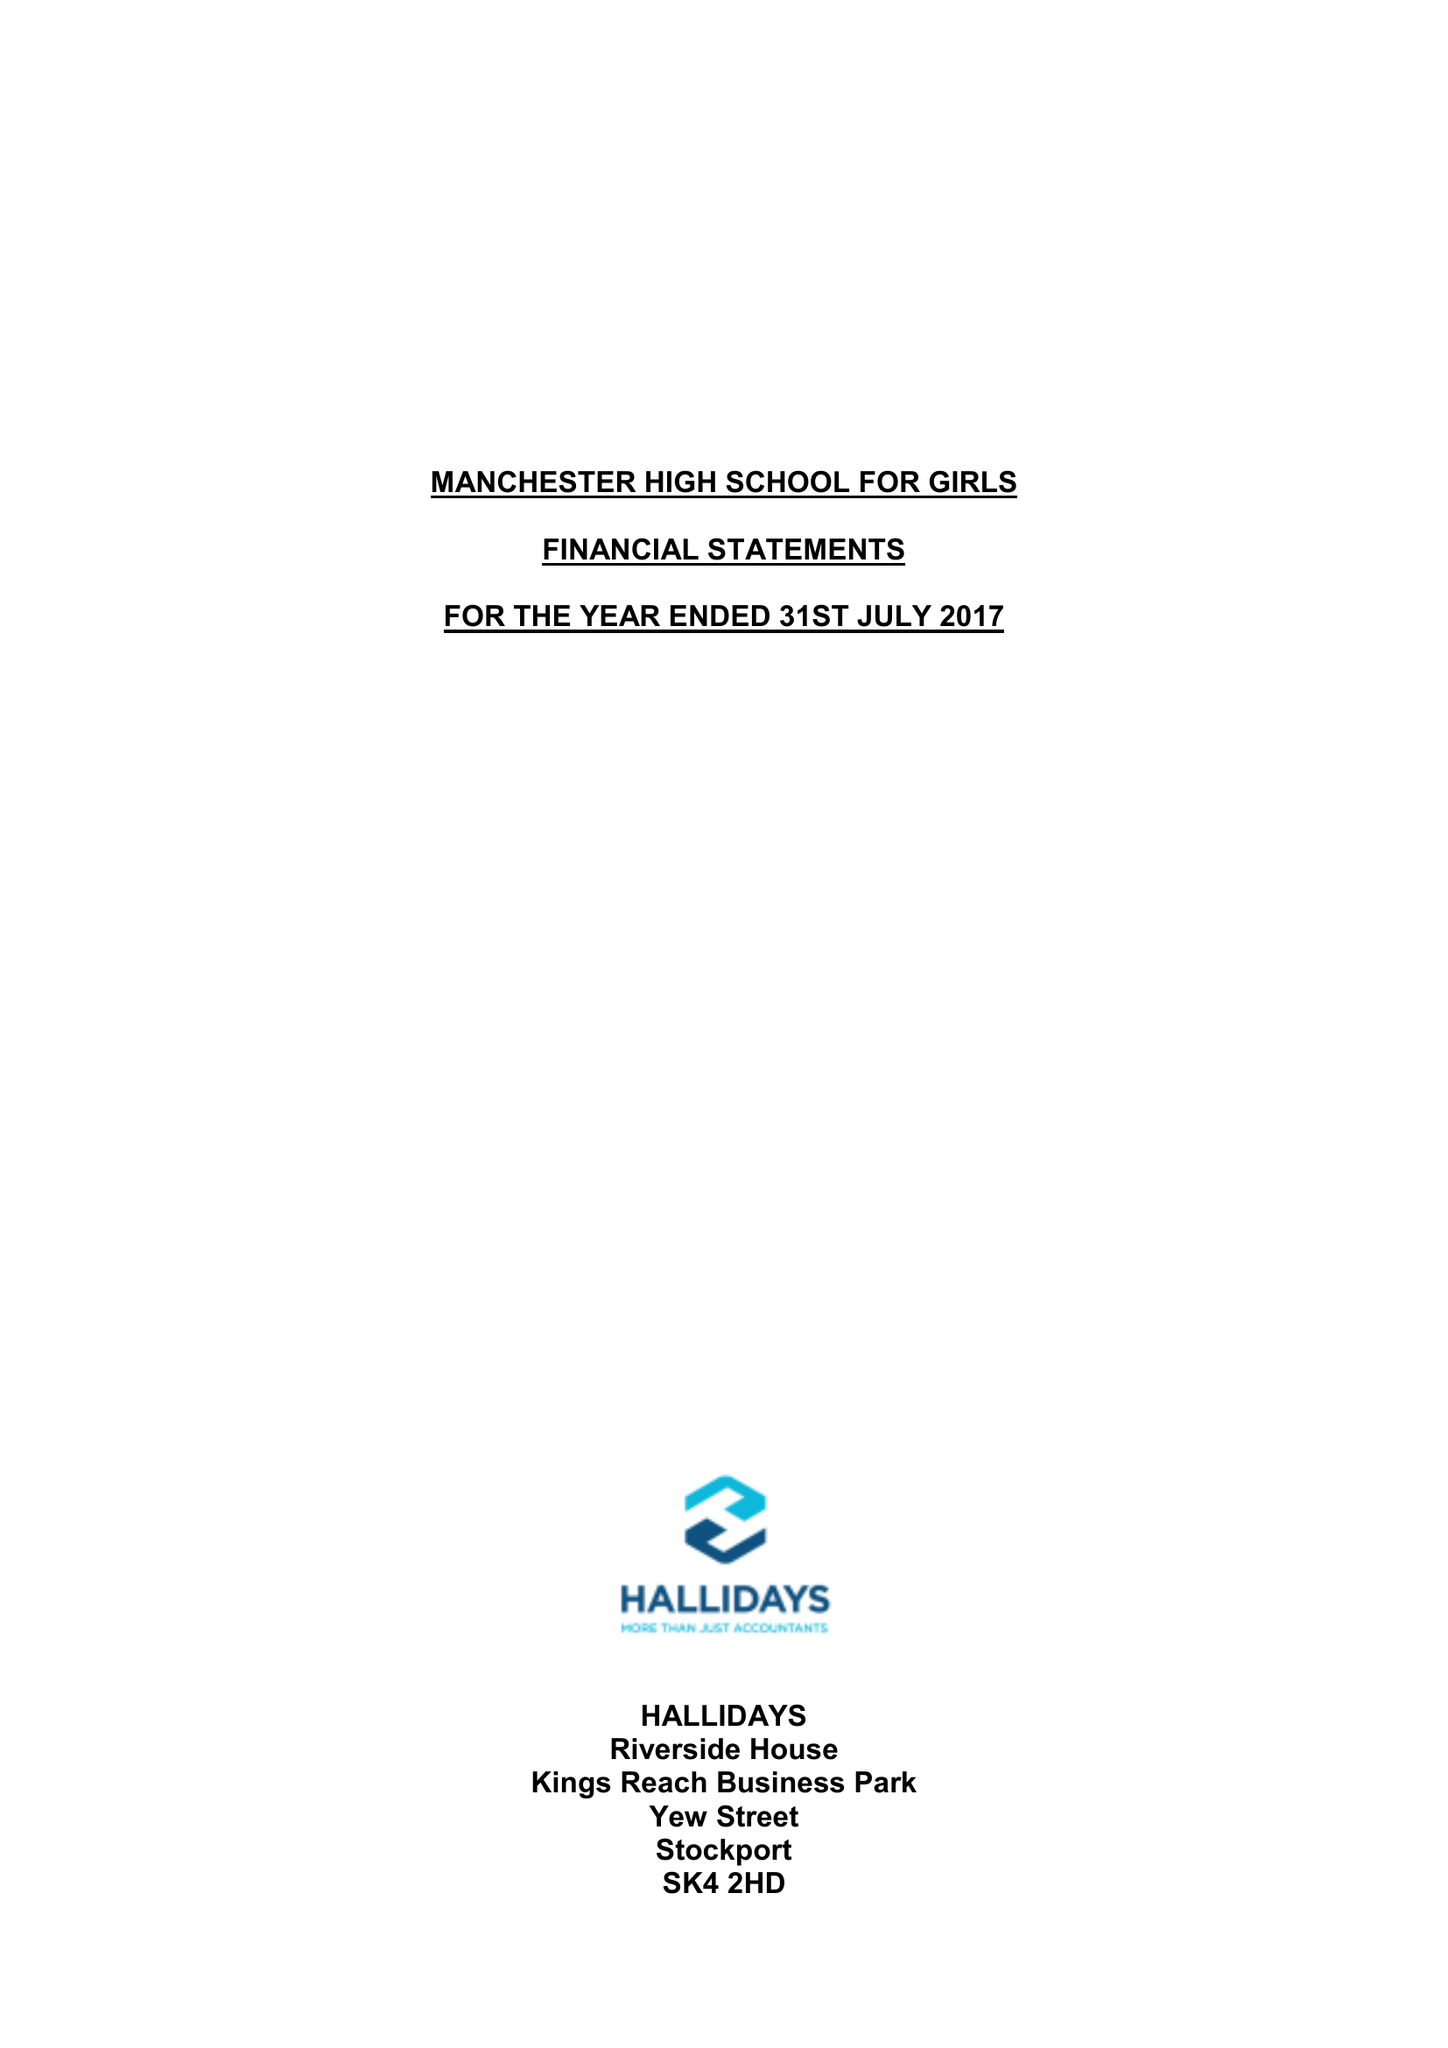What is the value for the charity_number?
Answer the question using a single word or phrase. 1164323 